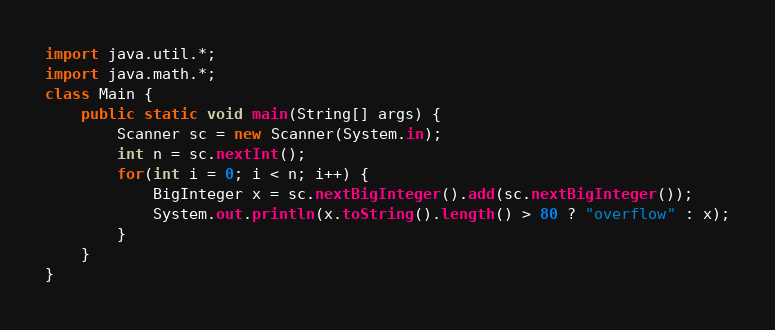Convert code to text. <code><loc_0><loc_0><loc_500><loc_500><_Java_>import java.util.*;
import java.math.*;
class Main {
	public static void main(String[] args) {
		Scanner sc = new Scanner(System.in);
		int n = sc.nextInt();
		for(int i = 0; i < n; i++) {
			BigInteger x = sc.nextBigInteger().add(sc.nextBigInteger());
			System.out.println(x.toString().length() > 80 ? "overflow" : x);
		}
	}
}</code> 